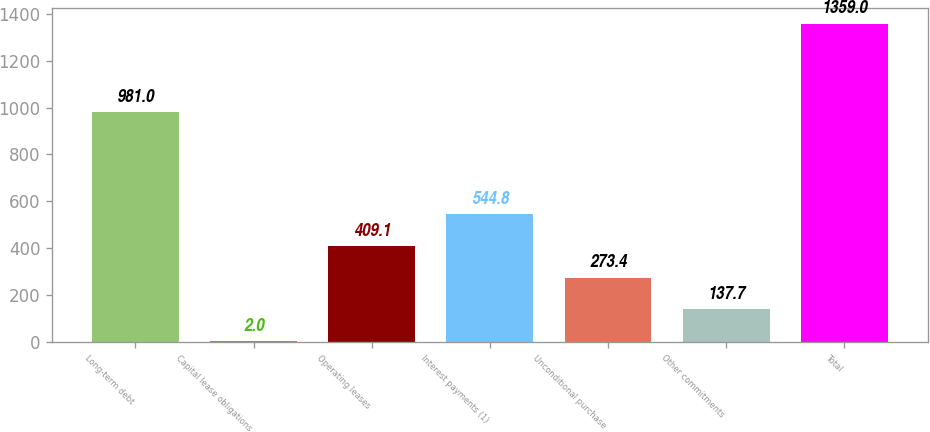<chart> <loc_0><loc_0><loc_500><loc_500><bar_chart><fcel>Long-term debt<fcel>Capital lease obligations<fcel>Operating leases<fcel>Interest payments (1)<fcel>Unconditional purchase<fcel>Other commitments<fcel>Total<nl><fcel>981<fcel>2<fcel>409.1<fcel>544.8<fcel>273.4<fcel>137.7<fcel>1359<nl></chart> 